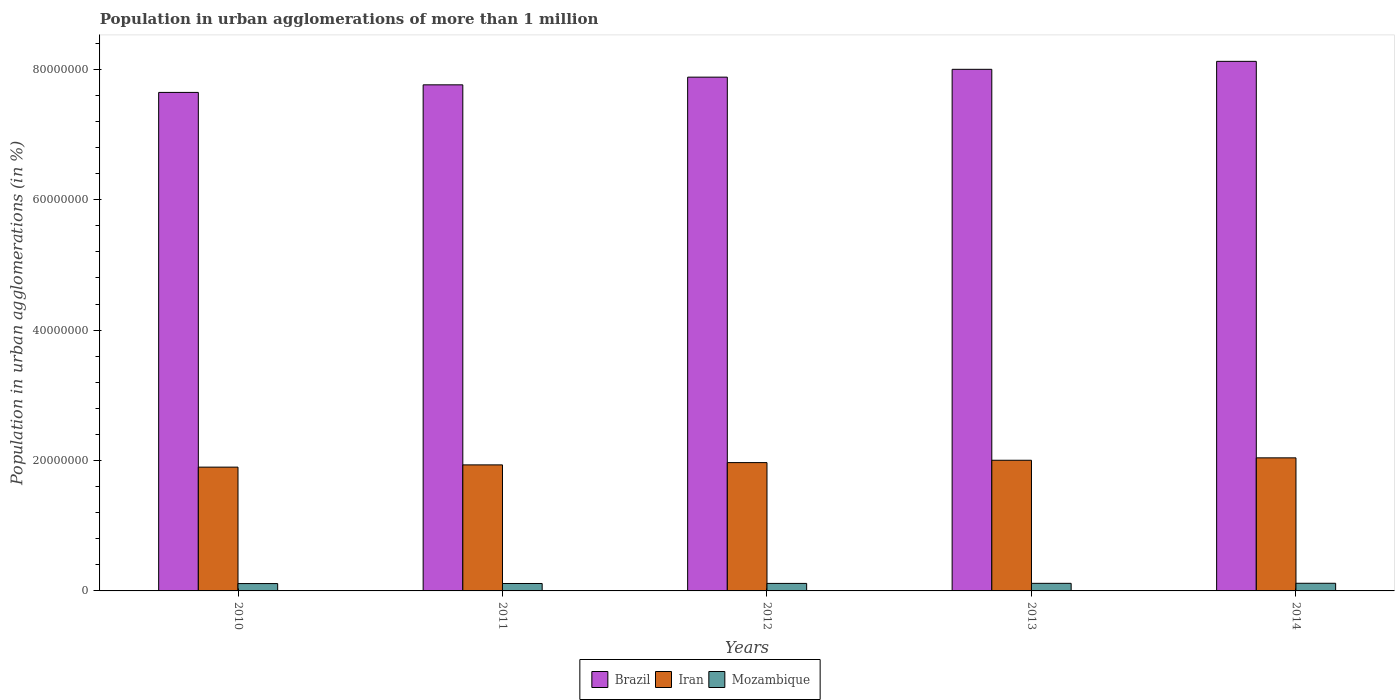How many different coloured bars are there?
Your answer should be very brief. 3. What is the label of the 3rd group of bars from the left?
Provide a succinct answer. 2012. What is the population in urban agglomerations in Brazil in 2010?
Your answer should be compact. 7.65e+07. Across all years, what is the maximum population in urban agglomerations in Brazil?
Offer a very short reply. 8.12e+07. Across all years, what is the minimum population in urban agglomerations in Mozambique?
Keep it short and to the point. 1.13e+06. In which year was the population in urban agglomerations in Iran minimum?
Your answer should be compact. 2010. What is the total population in urban agglomerations in Iran in the graph?
Provide a succinct answer. 9.84e+07. What is the difference between the population in urban agglomerations in Brazil in 2012 and that in 2013?
Your answer should be compact. -1.20e+06. What is the difference between the population in urban agglomerations in Mozambique in 2011 and the population in urban agglomerations in Iran in 2014?
Offer a very short reply. -1.93e+07. What is the average population in urban agglomerations in Iran per year?
Offer a terse response. 1.97e+07. In the year 2012, what is the difference between the population in urban agglomerations in Brazil and population in urban agglomerations in Mozambique?
Offer a terse response. 7.76e+07. In how many years, is the population in urban agglomerations in Brazil greater than 40000000 %?
Ensure brevity in your answer.  5. What is the ratio of the population in urban agglomerations in Iran in 2013 to that in 2014?
Your response must be concise. 0.98. Is the difference between the population in urban agglomerations in Brazil in 2011 and 2014 greater than the difference between the population in urban agglomerations in Mozambique in 2011 and 2014?
Ensure brevity in your answer.  No. What is the difference between the highest and the second highest population in urban agglomerations in Mozambique?
Your answer should be compact. 1.18e+04. What is the difference between the highest and the lowest population in urban agglomerations in Brazil?
Provide a short and direct response. 4.76e+06. Is the sum of the population in urban agglomerations in Brazil in 2010 and 2012 greater than the maximum population in urban agglomerations in Mozambique across all years?
Provide a short and direct response. Yes. What does the 1st bar from the left in 2011 represents?
Provide a succinct answer. Brazil. What does the 2nd bar from the right in 2014 represents?
Provide a succinct answer. Iran. How many years are there in the graph?
Keep it short and to the point. 5. Are the values on the major ticks of Y-axis written in scientific E-notation?
Give a very brief answer. No. Does the graph contain any zero values?
Your answer should be compact. No. What is the title of the graph?
Ensure brevity in your answer.  Population in urban agglomerations of more than 1 million. What is the label or title of the X-axis?
Your answer should be compact. Years. What is the label or title of the Y-axis?
Your answer should be compact. Population in urban agglomerations (in %). What is the Population in urban agglomerations (in %) in Brazil in 2010?
Offer a terse response. 7.65e+07. What is the Population in urban agglomerations (in %) in Iran in 2010?
Your answer should be very brief. 1.90e+07. What is the Population in urban agglomerations (in %) of Mozambique in 2010?
Your response must be concise. 1.13e+06. What is the Population in urban agglomerations (in %) in Brazil in 2011?
Offer a terse response. 7.76e+07. What is the Population in urban agglomerations (in %) in Iran in 2011?
Offer a terse response. 1.93e+07. What is the Population in urban agglomerations (in %) in Mozambique in 2011?
Provide a succinct answer. 1.14e+06. What is the Population in urban agglomerations (in %) of Brazil in 2012?
Keep it short and to the point. 7.88e+07. What is the Population in urban agglomerations (in %) of Iran in 2012?
Offer a terse response. 1.97e+07. What is the Population in urban agglomerations (in %) in Mozambique in 2012?
Your answer should be very brief. 1.15e+06. What is the Population in urban agglomerations (in %) in Brazil in 2013?
Keep it short and to the point. 8.00e+07. What is the Population in urban agglomerations (in %) in Iran in 2013?
Make the answer very short. 2.00e+07. What is the Population in urban agglomerations (in %) of Mozambique in 2013?
Provide a succinct answer. 1.16e+06. What is the Population in urban agglomerations (in %) in Brazil in 2014?
Provide a succinct answer. 8.12e+07. What is the Population in urban agglomerations (in %) in Iran in 2014?
Provide a short and direct response. 2.04e+07. What is the Population in urban agglomerations (in %) in Mozambique in 2014?
Provide a succinct answer. 1.17e+06. Across all years, what is the maximum Population in urban agglomerations (in %) of Brazil?
Keep it short and to the point. 8.12e+07. Across all years, what is the maximum Population in urban agglomerations (in %) in Iran?
Make the answer very short. 2.04e+07. Across all years, what is the maximum Population in urban agglomerations (in %) of Mozambique?
Make the answer very short. 1.17e+06. Across all years, what is the minimum Population in urban agglomerations (in %) of Brazil?
Your answer should be very brief. 7.65e+07. Across all years, what is the minimum Population in urban agglomerations (in %) in Iran?
Provide a succinct answer. 1.90e+07. Across all years, what is the minimum Population in urban agglomerations (in %) in Mozambique?
Provide a succinct answer. 1.13e+06. What is the total Population in urban agglomerations (in %) of Brazil in the graph?
Provide a short and direct response. 3.94e+08. What is the total Population in urban agglomerations (in %) in Iran in the graph?
Give a very brief answer. 9.84e+07. What is the total Population in urban agglomerations (in %) of Mozambique in the graph?
Keep it short and to the point. 5.75e+06. What is the difference between the Population in urban agglomerations (in %) in Brazil in 2010 and that in 2011?
Offer a terse response. -1.16e+06. What is the difference between the Population in urban agglomerations (in %) of Iran in 2010 and that in 2011?
Offer a very short reply. -3.43e+05. What is the difference between the Population in urban agglomerations (in %) of Mozambique in 2010 and that in 2011?
Give a very brief answer. -1.15e+04. What is the difference between the Population in urban agglomerations (in %) in Brazil in 2010 and that in 2012?
Offer a very short reply. -2.34e+06. What is the difference between the Population in urban agglomerations (in %) in Iran in 2010 and that in 2012?
Provide a succinct answer. -6.94e+05. What is the difference between the Population in urban agglomerations (in %) of Mozambique in 2010 and that in 2012?
Provide a succinct answer. -2.31e+04. What is the difference between the Population in urban agglomerations (in %) of Brazil in 2010 and that in 2013?
Your answer should be compact. -3.54e+06. What is the difference between the Population in urban agglomerations (in %) in Iran in 2010 and that in 2013?
Offer a terse response. -1.05e+06. What is the difference between the Population in urban agglomerations (in %) of Mozambique in 2010 and that in 2013?
Your answer should be compact. -3.48e+04. What is the difference between the Population in urban agglomerations (in %) of Brazil in 2010 and that in 2014?
Provide a short and direct response. -4.76e+06. What is the difference between the Population in urban agglomerations (in %) of Iran in 2010 and that in 2014?
Offer a terse response. -1.42e+06. What is the difference between the Population in urban agglomerations (in %) of Mozambique in 2010 and that in 2014?
Give a very brief answer. -4.66e+04. What is the difference between the Population in urban agglomerations (in %) of Brazil in 2011 and that in 2012?
Provide a succinct answer. -1.18e+06. What is the difference between the Population in urban agglomerations (in %) in Iran in 2011 and that in 2012?
Your answer should be compact. -3.51e+05. What is the difference between the Population in urban agglomerations (in %) of Mozambique in 2011 and that in 2012?
Provide a short and direct response. -1.16e+04. What is the difference between the Population in urban agglomerations (in %) of Brazil in 2011 and that in 2013?
Provide a succinct answer. -2.38e+06. What is the difference between the Population in urban agglomerations (in %) of Iran in 2011 and that in 2013?
Your answer should be very brief. -7.11e+05. What is the difference between the Population in urban agglomerations (in %) of Mozambique in 2011 and that in 2013?
Your answer should be very brief. -2.33e+04. What is the difference between the Population in urban agglomerations (in %) in Brazil in 2011 and that in 2014?
Ensure brevity in your answer.  -3.60e+06. What is the difference between the Population in urban agglomerations (in %) in Iran in 2011 and that in 2014?
Offer a very short reply. -1.08e+06. What is the difference between the Population in urban agglomerations (in %) in Mozambique in 2011 and that in 2014?
Your answer should be very brief. -3.51e+04. What is the difference between the Population in urban agglomerations (in %) in Brazil in 2012 and that in 2013?
Your answer should be compact. -1.20e+06. What is the difference between the Population in urban agglomerations (in %) of Iran in 2012 and that in 2013?
Provide a succinct answer. -3.59e+05. What is the difference between the Population in urban agglomerations (in %) in Mozambique in 2012 and that in 2013?
Your answer should be very brief. -1.17e+04. What is the difference between the Population in urban agglomerations (in %) in Brazil in 2012 and that in 2014?
Provide a succinct answer. -2.42e+06. What is the difference between the Population in urban agglomerations (in %) of Iran in 2012 and that in 2014?
Your response must be concise. -7.27e+05. What is the difference between the Population in urban agglomerations (in %) in Mozambique in 2012 and that in 2014?
Offer a very short reply. -2.35e+04. What is the difference between the Population in urban agglomerations (in %) of Brazil in 2013 and that in 2014?
Your answer should be compact. -1.22e+06. What is the difference between the Population in urban agglomerations (in %) in Iran in 2013 and that in 2014?
Your response must be concise. -3.68e+05. What is the difference between the Population in urban agglomerations (in %) of Mozambique in 2013 and that in 2014?
Offer a terse response. -1.18e+04. What is the difference between the Population in urban agglomerations (in %) in Brazil in 2010 and the Population in urban agglomerations (in %) in Iran in 2011?
Offer a terse response. 5.71e+07. What is the difference between the Population in urban agglomerations (in %) in Brazil in 2010 and the Population in urban agglomerations (in %) in Mozambique in 2011?
Your response must be concise. 7.53e+07. What is the difference between the Population in urban agglomerations (in %) in Iran in 2010 and the Population in urban agglomerations (in %) in Mozambique in 2011?
Provide a short and direct response. 1.78e+07. What is the difference between the Population in urban agglomerations (in %) of Brazil in 2010 and the Population in urban agglomerations (in %) of Iran in 2012?
Provide a succinct answer. 5.68e+07. What is the difference between the Population in urban agglomerations (in %) of Brazil in 2010 and the Population in urban agglomerations (in %) of Mozambique in 2012?
Your answer should be very brief. 7.53e+07. What is the difference between the Population in urban agglomerations (in %) of Iran in 2010 and the Population in urban agglomerations (in %) of Mozambique in 2012?
Provide a succinct answer. 1.78e+07. What is the difference between the Population in urban agglomerations (in %) of Brazil in 2010 and the Population in urban agglomerations (in %) of Iran in 2013?
Your answer should be very brief. 5.64e+07. What is the difference between the Population in urban agglomerations (in %) of Brazil in 2010 and the Population in urban agglomerations (in %) of Mozambique in 2013?
Offer a very short reply. 7.53e+07. What is the difference between the Population in urban agglomerations (in %) in Iran in 2010 and the Population in urban agglomerations (in %) in Mozambique in 2013?
Offer a very short reply. 1.78e+07. What is the difference between the Population in urban agglomerations (in %) in Brazil in 2010 and the Population in urban agglomerations (in %) in Iran in 2014?
Your answer should be compact. 5.60e+07. What is the difference between the Population in urban agglomerations (in %) in Brazil in 2010 and the Population in urban agglomerations (in %) in Mozambique in 2014?
Your answer should be very brief. 7.53e+07. What is the difference between the Population in urban agglomerations (in %) of Iran in 2010 and the Population in urban agglomerations (in %) of Mozambique in 2014?
Your response must be concise. 1.78e+07. What is the difference between the Population in urban agglomerations (in %) of Brazil in 2011 and the Population in urban agglomerations (in %) of Iran in 2012?
Offer a very short reply. 5.79e+07. What is the difference between the Population in urban agglomerations (in %) in Brazil in 2011 and the Population in urban agglomerations (in %) in Mozambique in 2012?
Give a very brief answer. 7.65e+07. What is the difference between the Population in urban agglomerations (in %) of Iran in 2011 and the Population in urban agglomerations (in %) of Mozambique in 2012?
Your answer should be very brief. 1.82e+07. What is the difference between the Population in urban agglomerations (in %) in Brazil in 2011 and the Population in urban agglomerations (in %) in Iran in 2013?
Keep it short and to the point. 5.76e+07. What is the difference between the Population in urban agglomerations (in %) of Brazil in 2011 and the Population in urban agglomerations (in %) of Mozambique in 2013?
Your answer should be compact. 7.64e+07. What is the difference between the Population in urban agglomerations (in %) in Iran in 2011 and the Population in urban agglomerations (in %) in Mozambique in 2013?
Ensure brevity in your answer.  1.82e+07. What is the difference between the Population in urban agglomerations (in %) of Brazil in 2011 and the Population in urban agglomerations (in %) of Iran in 2014?
Keep it short and to the point. 5.72e+07. What is the difference between the Population in urban agglomerations (in %) of Brazil in 2011 and the Population in urban agglomerations (in %) of Mozambique in 2014?
Provide a succinct answer. 7.64e+07. What is the difference between the Population in urban agglomerations (in %) of Iran in 2011 and the Population in urban agglomerations (in %) of Mozambique in 2014?
Offer a very short reply. 1.82e+07. What is the difference between the Population in urban agglomerations (in %) in Brazil in 2012 and the Population in urban agglomerations (in %) in Iran in 2013?
Offer a terse response. 5.88e+07. What is the difference between the Population in urban agglomerations (in %) in Brazil in 2012 and the Population in urban agglomerations (in %) in Mozambique in 2013?
Provide a short and direct response. 7.76e+07. What is the difference between the Population in urban agglomerations (in %) in Iran in 2012 and the Population in urban agglomerations (in %) in Mozambique in 2013?
Offer a very short reply. 1.85e+07. What is the difference between the Population in urban agglomerations (in %) of Brazil in 2012 and the Population in urban agglomerations (in %) of Iran in 2014?
Your answer should be very brief. 5.84e+07. What is the difference between the Population in urban agglomerations (in %) in Brazil in 2012 and the Population in urban agglomerations (in %) in Mozambique in 2014?
Your response must be concise. 7.76e+07. What is the difference between the Population in urban agglomerations (in %) in Iran in 2012 and the Population in urban agglomerations (in %) in Mozambique in 2014?
Offer a very short reply. 1.85e+07. What is the difference between the Population in urban agglomerations (in %) in Brazil in 2013 and the Population in urban agglomerations (in %) in Iran in 2014?
Your response must be concise. 5.96e+07. What is the difference between the Population in urban agglomerations (in %) of Brazil in 2013 and the Population in urban agglomerations (in %) of Mozambique in 2014?
Give a very brief answer. 7.88e+07. What is the difference between the Population in urban agglomerations (in %) of Iran in 2013 and the Population in urban agglomerations (in %) of Mozambique in 2014?
Your response must be concise. 1.89e+07. What is the average Population in urban agglomerations (in %) in Brazil per year?
Offer a terse response. 7.88e+07. What is the average Population in urban agglomerations (in %) of Iran per year?
Provide a succinct answer. 1.97e+07. What is the average Population in urban agglomerations (in %) in Mozambique per year?
Make the answer very short. 1.15e+06. In the year 2010, what is the difference between the Population in urban agglomerations (in %) of Brazil and Population in urban agglomerations (in %) of Iran?
Your answer should be very brief. 5.75e+07. In the year 2010, what is the difference between the Population in urban agglomerations (in %) in Brazil and Population in urban agglomerations (in %) in Mozambique?
Provide a short and direct response. 7.53e+07. In the year 2010, what is the difference between the Population in urban agglomerations (in %) of Iran and Population in urban agglomerations (in %) of Mozambique?
Make the answer very short. 1.79e+07. In the year 2011, what is the difference between the Population in urban agglomerations (in %) in Brazil and Population in urban agglomerations (in %) in Iran?
Keep it short and to the point. 5.83e+07. In the year 2011, what is the difference between the Population in urban agglomerations (in %) of Brazil and Population in urban agglomerations (in %) of Mozambique?
Ensure brevity in your answer.  7.65e+07. In the year 2011, what is the difference between the Population in urban agglomerations (in %) in Iran and Population in urban agglomerations (in %) in Mozambique?
Your response must be concise. 1.82e+07. In the year 2012, what is the difference between the Population in urban agglomerations (in %) of Brazil and Population in urban agglomerations (in %) of Iran?
Offer a terse response. 5.91e+07. In the year 2012, what is the difference between the Population in urban agglomerations (in %) in Brazil and Population in urban agglomerations (in %) in Mozambique?
Your response must be concise. 7.76e+07. In the year 2012, what is the difference between the Population in urban agglomerations (in %) in Iran and Population in urban agglomerations (in %) in Mozambique?
Ensure brevity in your answer.  1.85e+07. In the year 2013, what is the difference between the Population in urban agglomerations (in %) in Brazil and Population in urban agglomerations (in %) in Iran?
Offer a very short reply. 6.00e+07. In the year 2013, what is the difference between the Population in urban agglomerations (in %) of Brazil and Population in urban agglomerations (in %) of Mozambique?
Give a very brief answer. 7.88e+07. In the year 2013, what is the difference between the Population in urban agglomerations (in %) in Iran and Population in urban agglomerations (in %) in Mozambique?
Offer a terse response. 1.89e+07. In the year 2014, what is the difference between the Population in urban agglomerations (in %) of Brazil and Population in urban agglomerations (in %) of Iran?
Give a very brief answer. 6.08e+07. In the year 2014, what is the difference between the Population in urban agglomerations (in %) in Brazil and Population in urban agglomerations (in %) in Mozambique?
Ensure brevity in your answer.  8.00e+07. In the year 2014, what is the difference between the Population in urban agglomerations (in %) of Iran and Population in urban agglomerations (in %) of Mozambique?
Offer a very short reply. 1.92e+07. What is the ratio of the Population in urban agglomerations (in %) of Iran in 2010 to that in 2011?
Keep it short and to the point. 0.98. What is the ratio of the Population in urban agglomerations (in %) in Brazil in 2010 to that in 2012?
Your response must be concise. 0.97. What is the ratio of the Population in urban agglomerations (in %) of Iran in 2010 to that in 2012?
Your answer should be very brief. 0.96. What is the ratio of the Population in urban agglomerations (in %) of Mozambique in 2010 to that in 2012?
Your answer should be compact. 0.98. What is the ratio of the Population in urban agglomerations (in %) of Brazil in 2010 to that in 2013?
Keep it short and to the point. 0.96. What is the ratio of the Population in urban agglomerations (in %) of Mozambique in 2010 to that in 2013?
Your answer should be compact. 0.97. What is the ratio of the Population in urban agglomerations (in %) of Brazil in 2010 to that in 2014?
Give a very brief answer. 0.94. What is the ratio of the Population in urban agglomerations (in %) of Iran in 2010 to that in 2014?
Your answer should be very brief. 0.93. What is the ratio of the Population in urban agglomerations (in %) of Mozambique in 2010 to that in 2014?
Offer a very short reply. 0.96. What is the ratio of the Population in urban agglomerations (in %) of Iran in 2011 to that in 2012?
Provide a succinct answer. 0.98. What is the ratio of the Population in urban agglomerations (in %) in Mozambique in 2011 to that in 2012?
Keep it short and to the point. 0.99. What is the ratio of the Population in urban agglomerations (in %) of Brazil in 2011 to that in 2013?
Your response must be concise. 0.97. What is the ratio of the Population in urban agglomerations (in %) of Iran in 2011 to that in 2013?
Keep it short and to the point. 0.96. What is the ratio of the Population in urban agglomerations (in %) of Mozambique in 2011 to that in 2013?
Make the answer very short. 0.98. What is the ratio of the Population in urban agglomerations (in %) in Brazil in 2011 to that in 2014?
Your answer should be very brief. 0.96. What is the ratio of the Population in urban agglomerations (in %) in Iran in 2011 to that in 2014?
Ensure brevity in your answer.  0.95. What is the ratio of the Population in urban agglomerations (in %) of Mozambique in 2011 to that in 2014?
Offer a very short reply. 0.97. What is the ratio of the Population in urban agglomerations (in %) of Iran in 2012 to that in 2013?
Keep it short and to the point. 0.98. What is the ratio of the Population in urban agglomerations (in %) of Brazil in 2012 to that in 2014?
Your answer should be very brief. 0.97. What is the ratio of the Population in urban agglomerations (in %) of Iran in 2012 to that in 2014?
Make the answer very short. 0.96. What is the ratio of the Population in urban agglomerations (in %) in Mozambique in 2013 to that in 2014?
Your answer should be compact. 0.99. What is the difference between the highest and the second highest Population in urban agglomerations (in %) of Brazil?
Make the answer very short. 1.22e+06. What is the difference between the highest and the second highest Population in urban agglomerations (in %) in Iran?
Keep it short and to the point. 3.68e+05. What is the difference between the highest and the second highest Population in urban agglomerations (in %) of Mozambique?
Keep it short and to the point. 1.18e+04. What is the difference between the highest and the lowest Population in urban agglomerations (in %) in Brazil?
Offer a terse response. 4.76e+06. What is the difference between the highest and the lowest Population in urban agglomerations (in %) of Iran?
Give a very brief answer. 1.42e+06. What is the difference between the highest and the lowest Population in urban agglomerations (in %) in Mozambique?
Your answer should be very brief. 4.66e+04. 